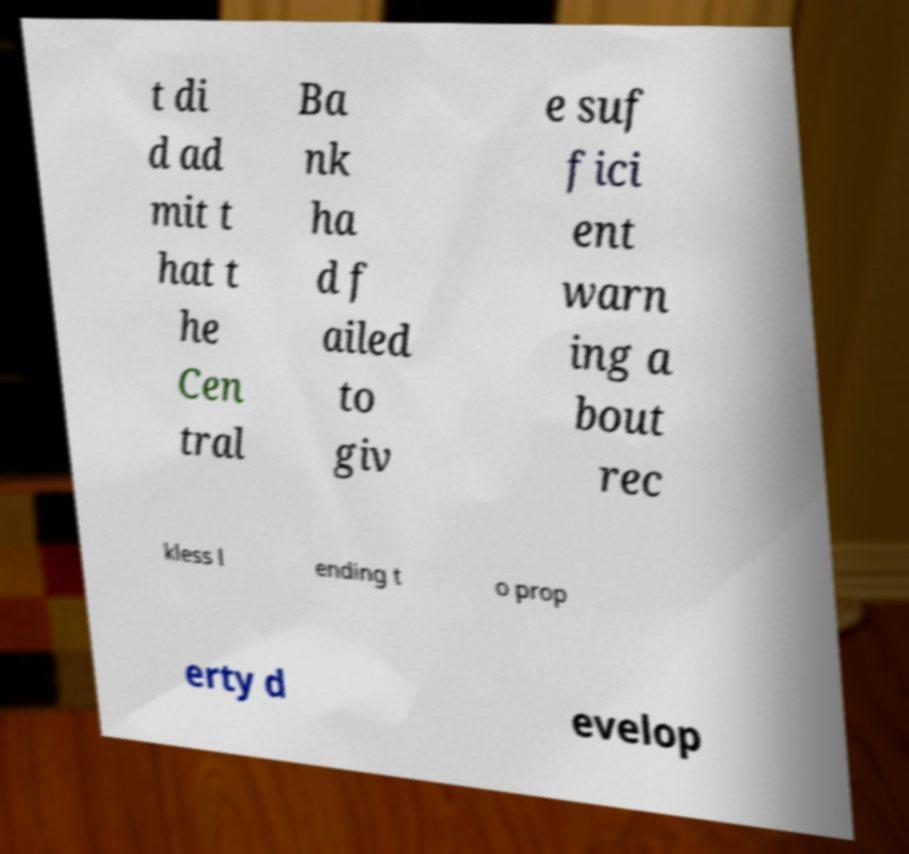Please identify and transcribe the text found in this image. t di d ad mit t hat t he Cen tral Ba nk ha d f ailed to giv e suf fici ent warn ing a bout rec kless l ending t o prop erty d evelop 